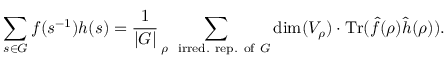Convert formula to latex. <formula><loc_0><loc_0><loc_500><loc_500>\sum _ { s \in G } f ( s ^ { - 1 } ) h ( s ) = { \frac { 1 } { | G | } } \sum _ { \rho \, { i r r e d . } { r e p . } { o f } G } \dim ( V _ { \rho } ) \cdot { T r } ( { \hat { f } } ( \rho ) { \hat { h } } ( \rho ) ) .</formula> 